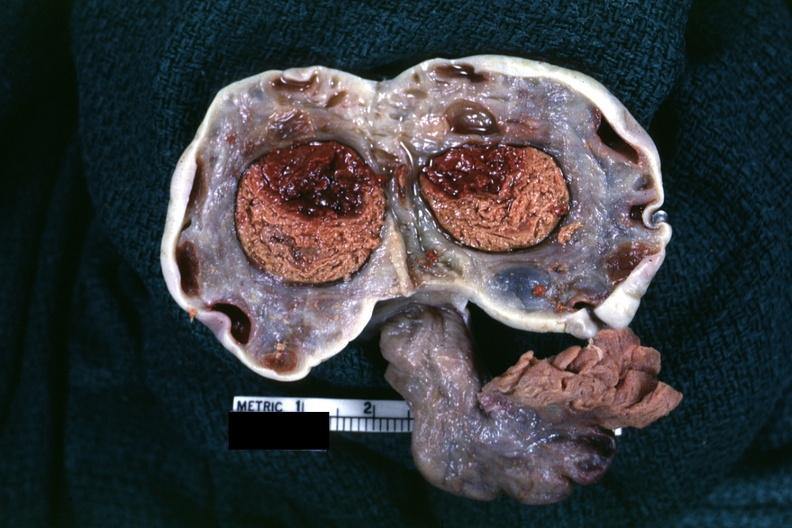what did not mention?
Answer the question using a single word or phrase. Fixed tissue large hemorrhagic cyst in ovary with several corpora lutea for size comparison sure of this diagnosis but sure looks like on autopsy diagnoses 